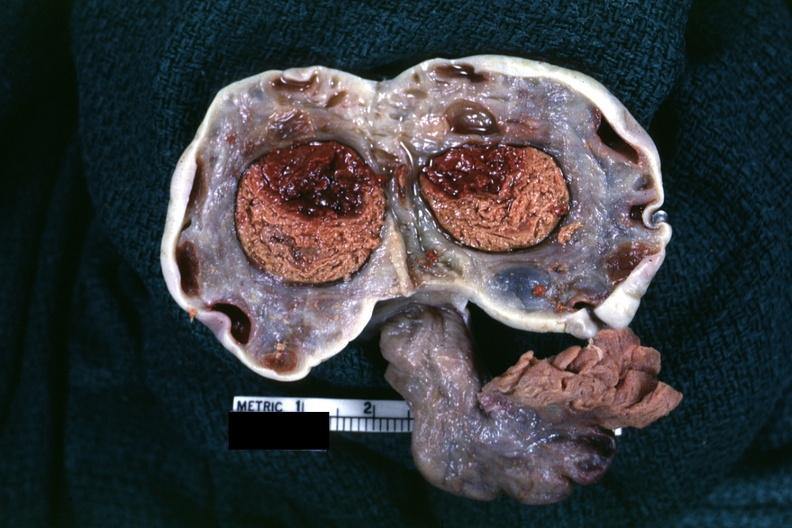what did not mention?
Answer the question using a single word or phrase. Fixed tissue large hemorrhagic cyst in ovary with several corpora lutea for size comparison sure of this diagnosis but sure looks like on autopsy diagnoses 